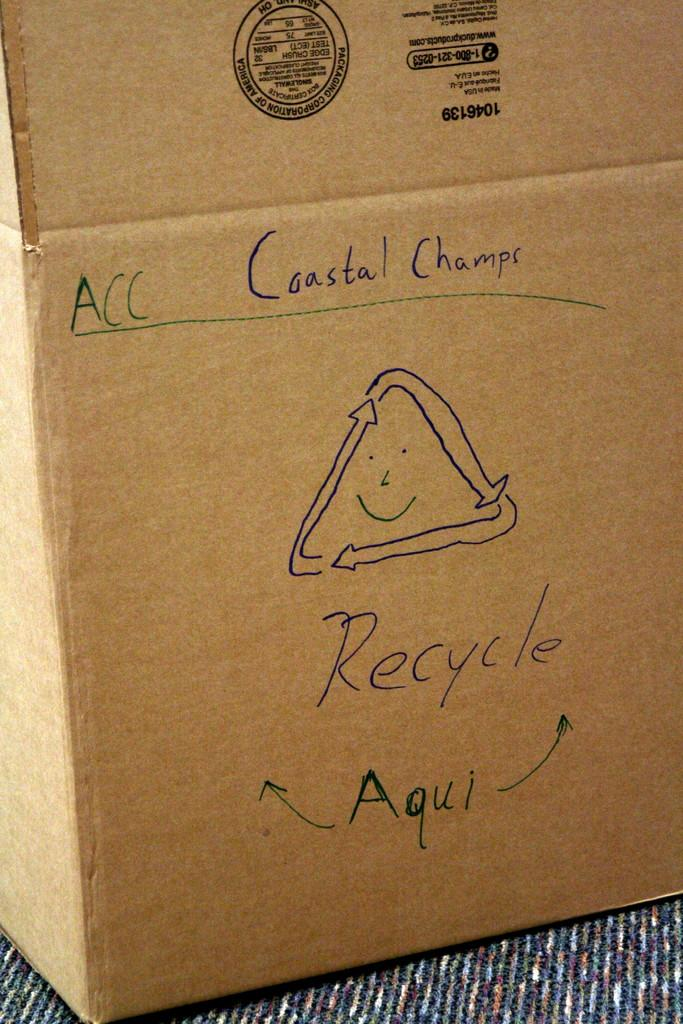Provide a one-sentence caption for the provided image. A cardboard box that has a recyling symbol and the word recycle written with black ink. 